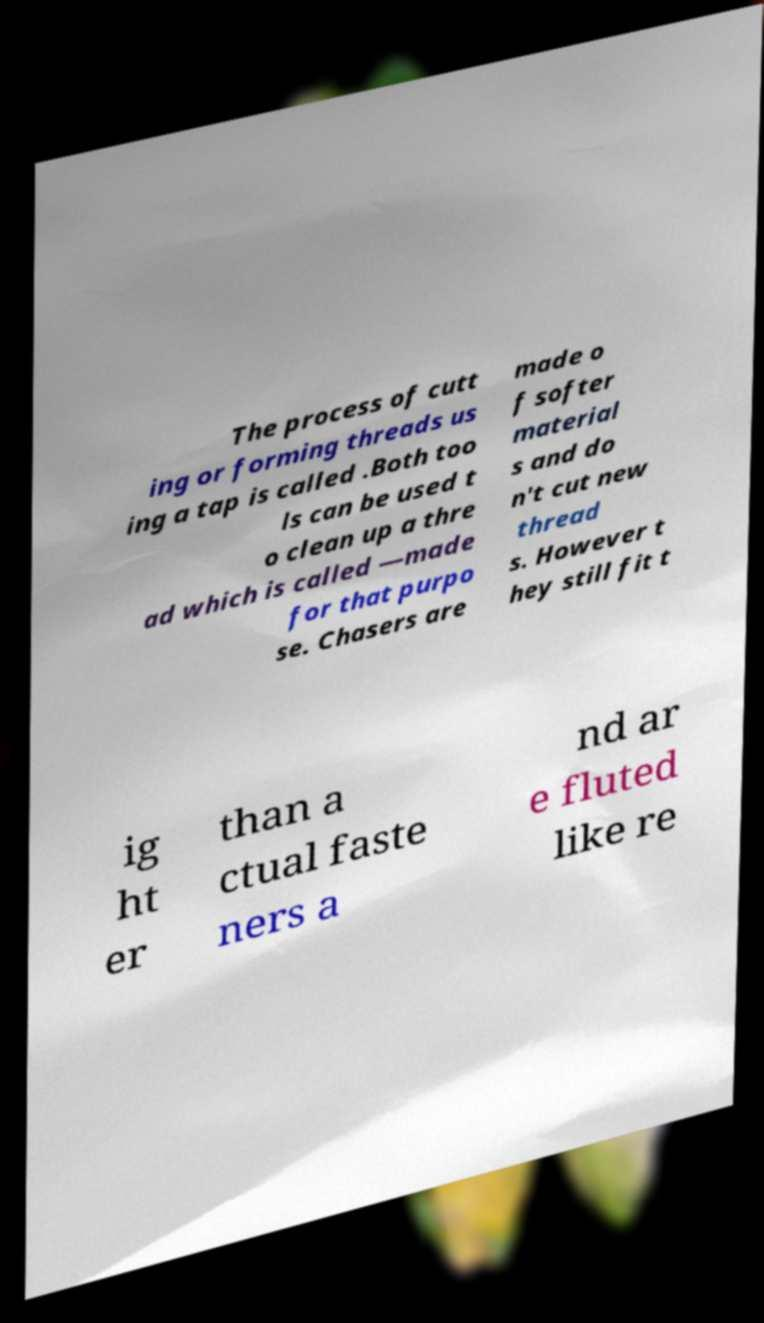I need the written content from this picture converted into text. Can you do that? The process of cutt ing or forming threads us ing a tap is called .Both too ls can be used t o clean up a thre ad which is called —made for that purpo se. Chasers are made o f softer material s and do n't cut new thread s. However t hey still fit t ig ht er than a ctual faste ners a nd ar e fluted like re 